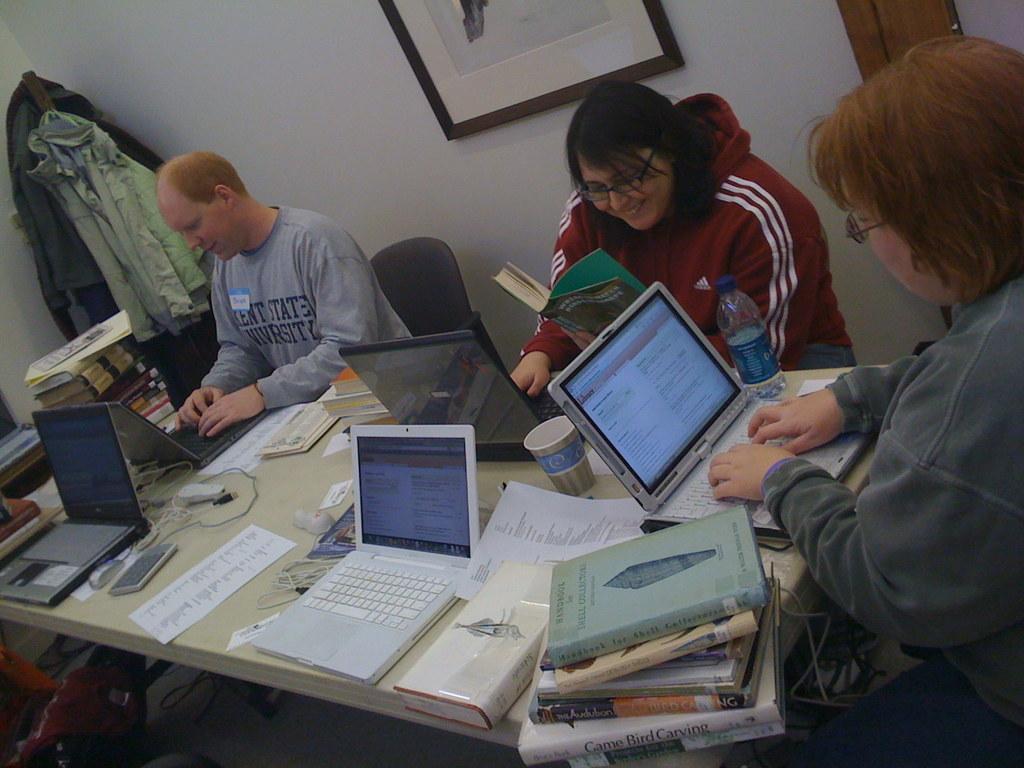How would you summarize this image in a sentence or two? In this image there is a table, on that table there are books, papers, cup, laptops, around the table there are three persons sitting on chairs, in the background there is a wall to that wall there is a frame and clothes. 